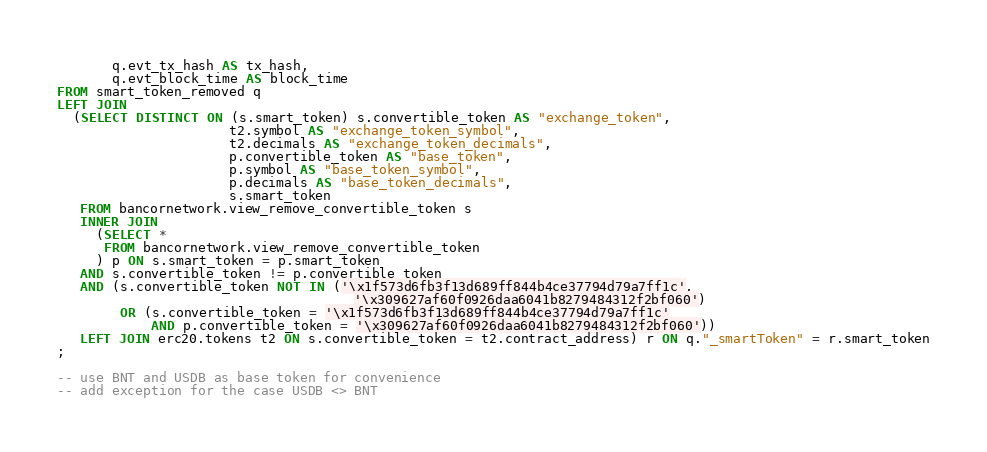<code> <loc_0><loc_0><loc_500><loc_500><_SQL_>       q.evt_tx_hash AS tx_hash,
       q.evt_block_time AS block_time
FROM smart_token_removed q
LEFT JOIN
  (SELECT DISTINCT ON (s.smart_token) s.convertible_token AS "exchange_token",
                      t2.symbol AS "exchange_token_symbol",
                      t2.decimals AS "exchange_token_decimals",
                      p.convertible_token AS "base_token",
                      p.symbol AS "base_token_symbol",
                      p.decimals AS "base_token_decimals",
                      s.smart_token
   FROM bancornetwork.view_remove_convertible_token s
   INNER JOIN
     (SELECT *
      FROM bancornetwork.view_remove_convertible_token
     ) p ON s.smart_token = p.smart_token
   AND s.convertible_token != p.convertible_token
   AND (s.convertible_token NOT IN ('\x1f573d6fb3f13d689ff844b4ce37794d79a7ff1c',
                                      '\x309627af60f0926daa6041b8279484312f2bf060')
        OR (s.convertible_token = '\x1f573d6fb3f13d689ff844b4ce37794d79a7ff1c'
            AND p.convertible_token = '\x309627af60f0926daa6041b8279484312f2bf060'))
   LEFT JOIN erc20.tokens t2 ON s.convertible_token = t2.contract_address) r ON q."_smartToken" = r.smart_token
;

-- use BNT and USDB as base token for convenience
-- add exception for the case USDB <> BNT
</code> 